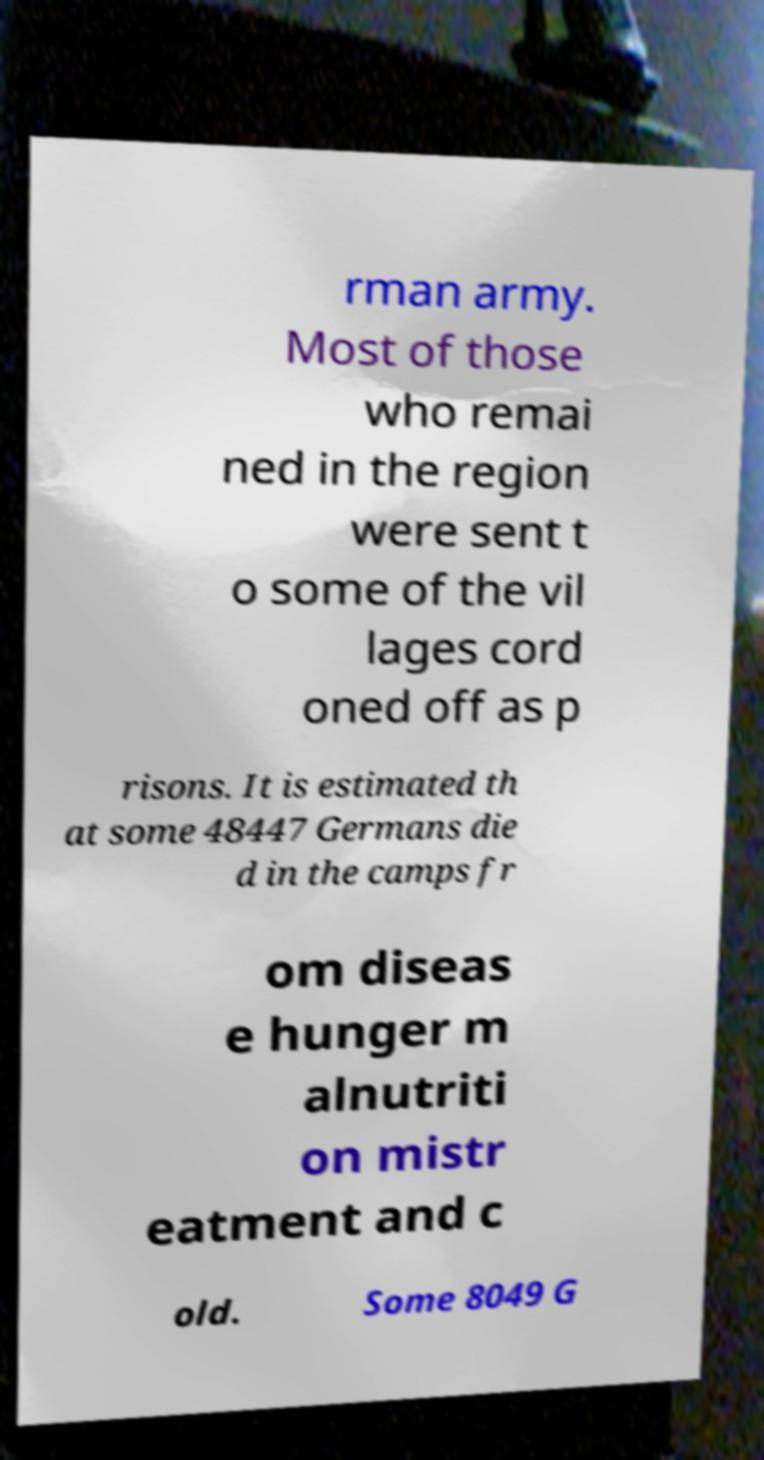What messages or text are displayed in this image? I need them in a readable, typed format. rman army. Most of those who remai ned in the region were sent t o some of the vil lages cord oned off as p risons. It is estimated th at some 48447 Germans die d in the camps fr om diseas e hunger m alnutriti on mistr eatment and c old. Some 8049 G 